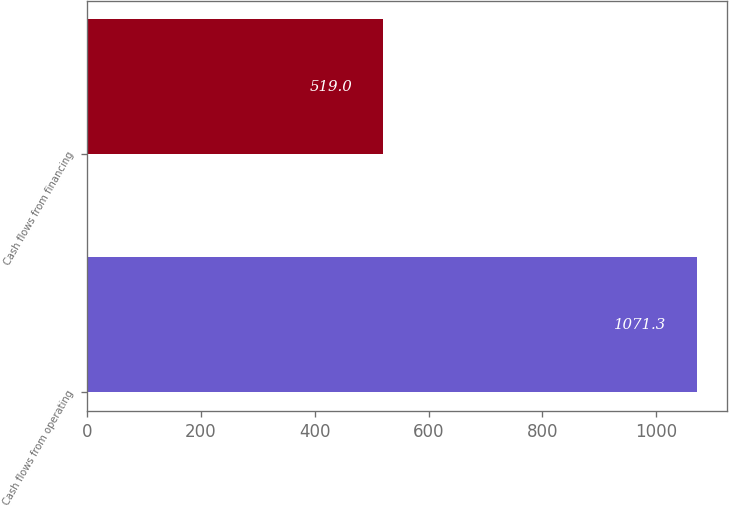Convert chart. <chart><loc_0><loc_0><loc_500><loc_500><bar_chart><fcel>Cash flows from operating<fcel>Cash flows from financing<nl><fcel>1071.3<fcel>519<nl></chart> 